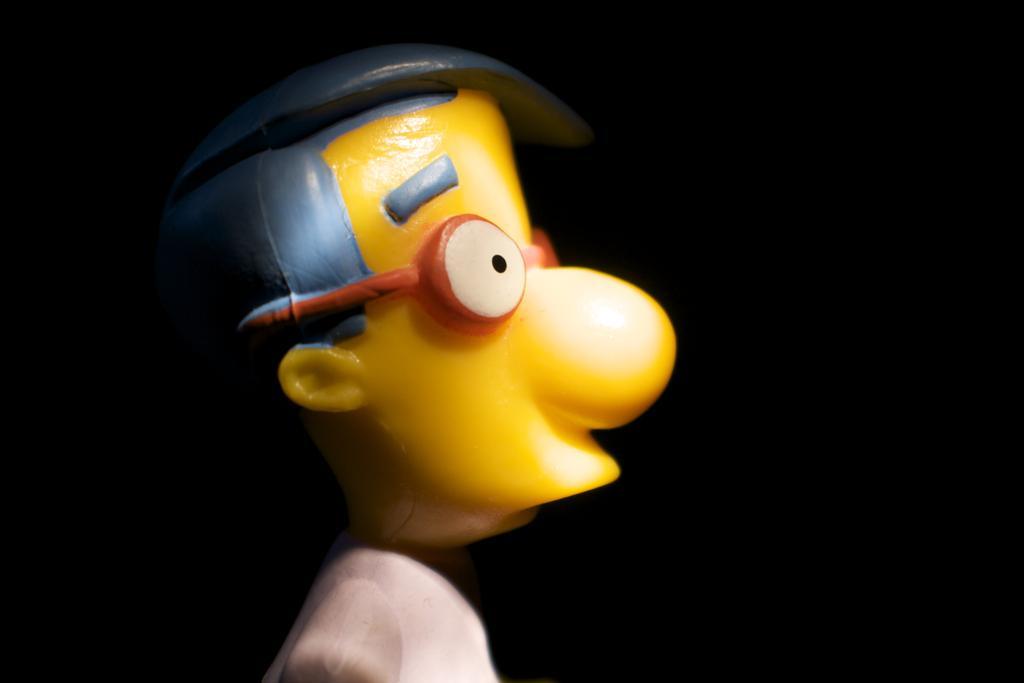Could you give a brief overview of what you see in this image? In this image we can see a toy which looks like a person. The background of the image is dark. 